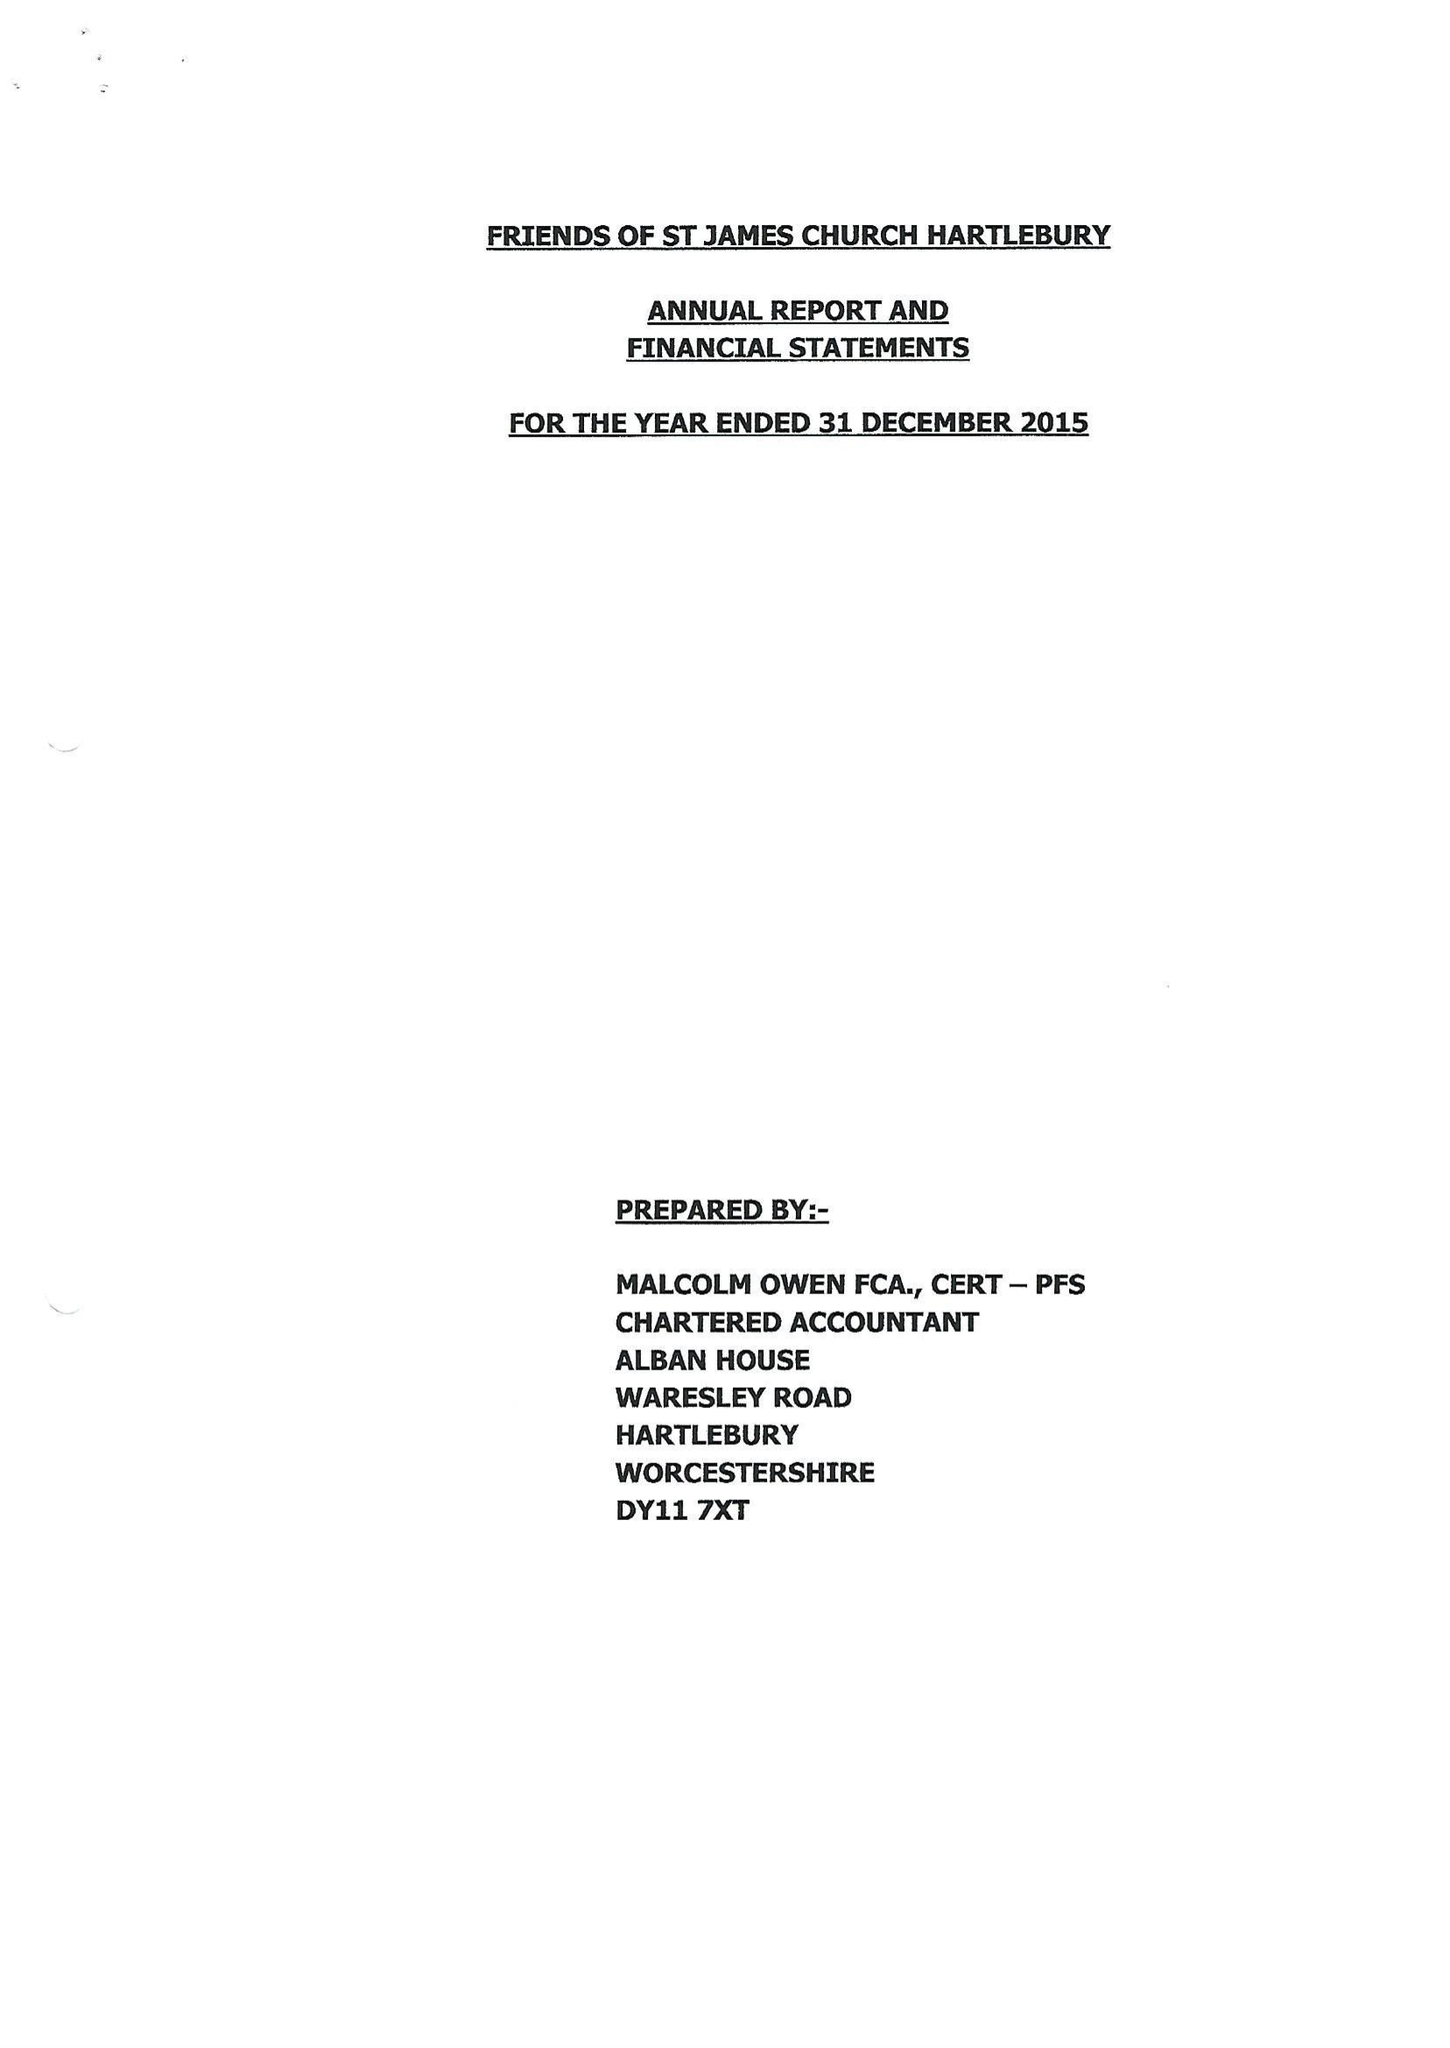What is the value for the income_annually_in_british_pounds?
Answer the question using a single word or phrase. 25557.00 